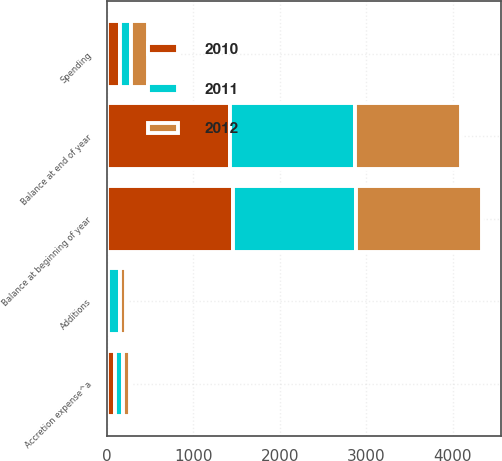Convert chart. <chart><loc_0><loc_0><loc_500><loc_500><stacked_bar_chart><ecel><fcel>Balance at beginning of year<fcel>Accretion expense^a<fcel>Additions<fcel>Spending<fcel>Balance at end of year<nl><fcel>2012<fcel>1453<fcel>80<fcel>70<fcel>199<fcel>1222<nl><fcel>2011<fcel>1422<fcel>88<fcel>132<fcel>121<fcel>1453<nl><fcel>2010<fcel>1464<fcel>97<fcel>19<fcel>158<fcel>1422<nl></chart> 